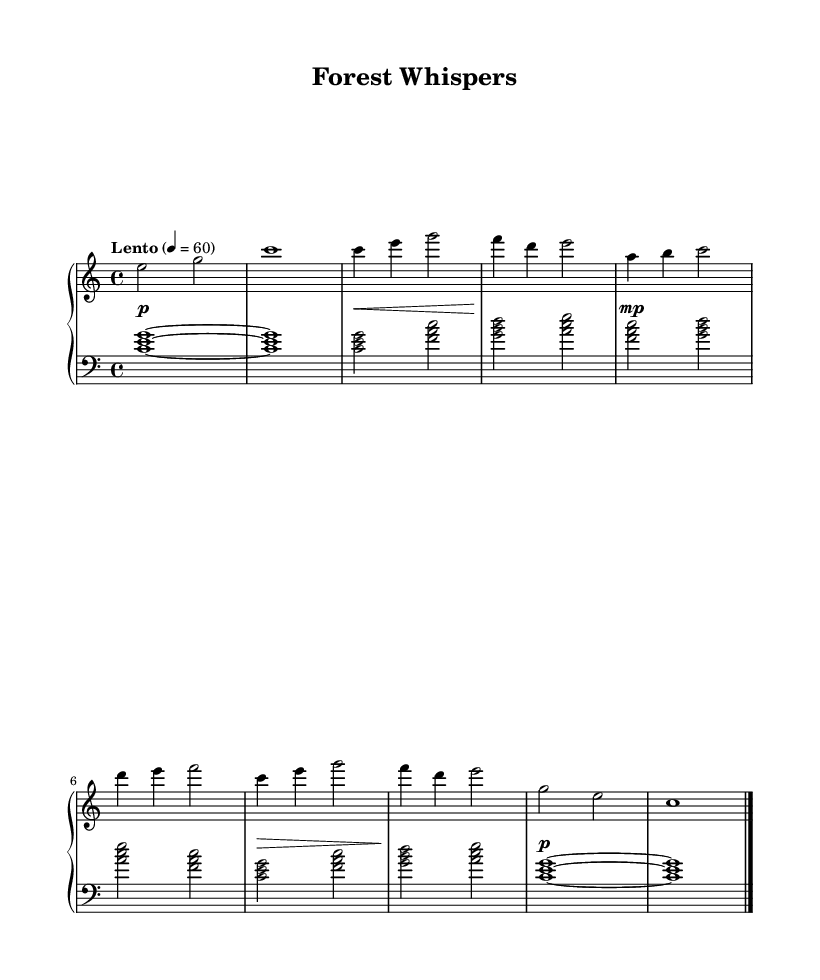What is the key signature of this music? The key signature is indicated at the beginning of the staff. It shows the absence of sharps or flats, indicating that it is in C major.
Answer: C major What is the time signature of this music? The time signature is indicated at the beginning of the staff as 4/4, which means there are four beats in a measure and the quarter note gets one beat.
Answer: 4/4 What is the tempo marking for this piece? The tempo marking appears above the staff and indicates the speed of the piece. It says "Lento" with a metronome marking of 60, suggesting a slow tempo.
Answer: Lento How many sections are there in the composition? The score includes three distinct sections: Section A, Section B, and the reprise of Section A (A'). This can be observed in the structure outlined in the music.
Answer: Three What dynamic markings are present in the music? The dynamics consist of several markings that indicate the volume levels throughout the piece. They show changes from piano (soft) to mezzo-piano and other markings, demonstrating dynamic variation.
Answer: piano, mezzo-piano What is the last chord of the composition? The last chord is shown at the end of the score, which indicates the final notes to resolve the piece. The last note is C major, indicating the piece concludes on this consonant chord.
Answer: C major How does the left hand’s part relate to the right hand’s part? The left hand plays chordal figures that support the melody in the right hand. The harmony is built from arpeggiated chords corresponding to the notes played by the right hand, thus creating a cohesive sound.
Answer: Complementary 